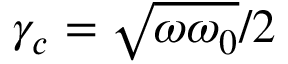Convert formula to latex. <formula><loc_0><loc_0><loc_500><loc_500>\gamma _ { c } = \sqrt { \omega \omega _ { 0 } } / 2</formula> 